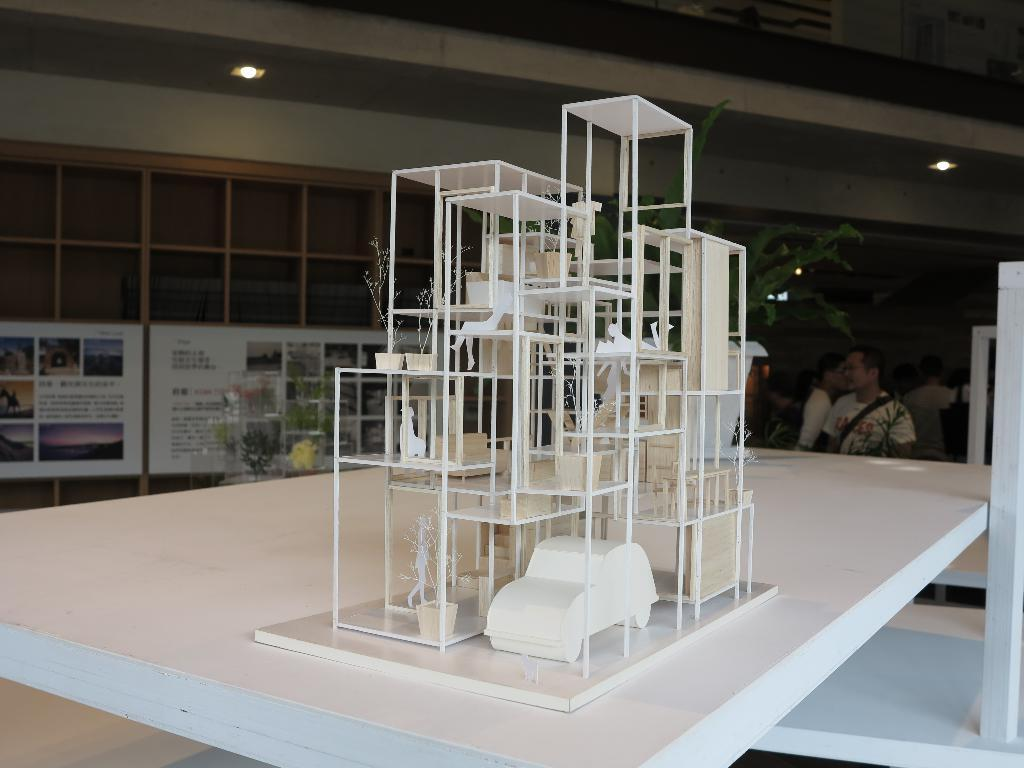What is the main subject of the image? There is a miniature of a house in the image. What can be seen in the background of the image? There are people sitting in the background of the image. What type of surface is present in the image? There are white boards in the image. What color is the wall in the image? The wall is cream-colored. What is the source of light in the image? There is a light visible in the image. How many boundaries are visible in the image? There are no boundaries visible in the image. What type of baby is present in the image? There is no baby present in the image. 